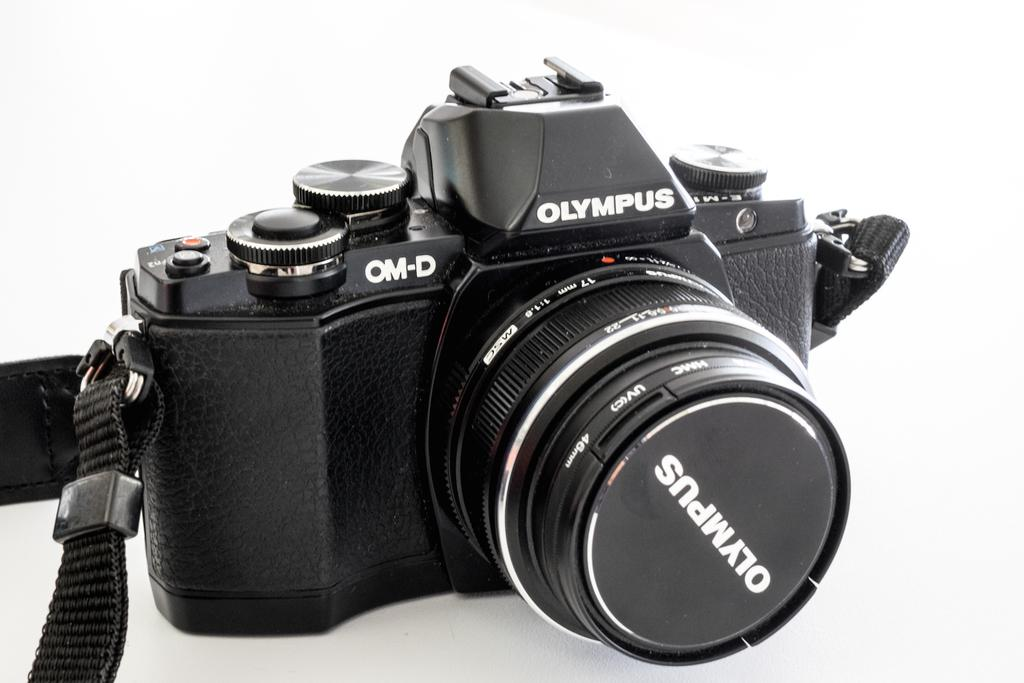What is the main subject of the image? The main subject of the image is a camera. Can you describe the camera in the image? The camera is in the center of the image and has text visible on it. What is the color of the background in the image? The background of the image is white. How does the kitty help with the distribution of the camera in the image? There is no kitty present in the image, and therefore no distribution or assistance from a kitty can be observed. 